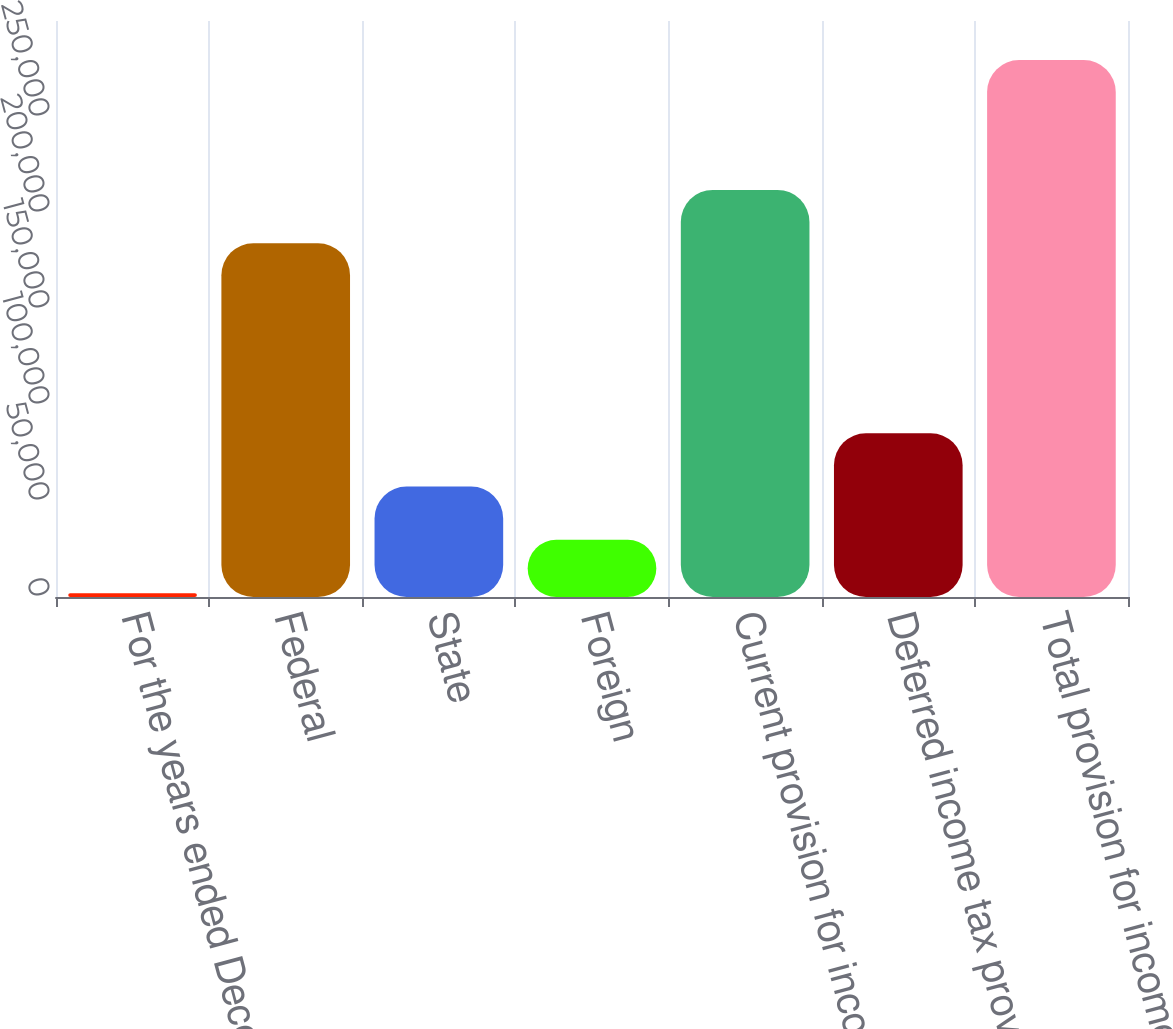Convert chart. <chart><loc_0><loc_0><loc_500><loc_500><bar_chart><fcel>For the years ended December<fcel>Federal<fcel>State<fcel>Foreign<fcel>Current provision for income<fcel>Deferred income tax provision<fcel>Total provision for income<nl><fcel>2005<fcel>184271<fcel>57540.4<fcel>29772.7<fcel>212039<fcel>85308.1<fcel>279682<nl></chart> 